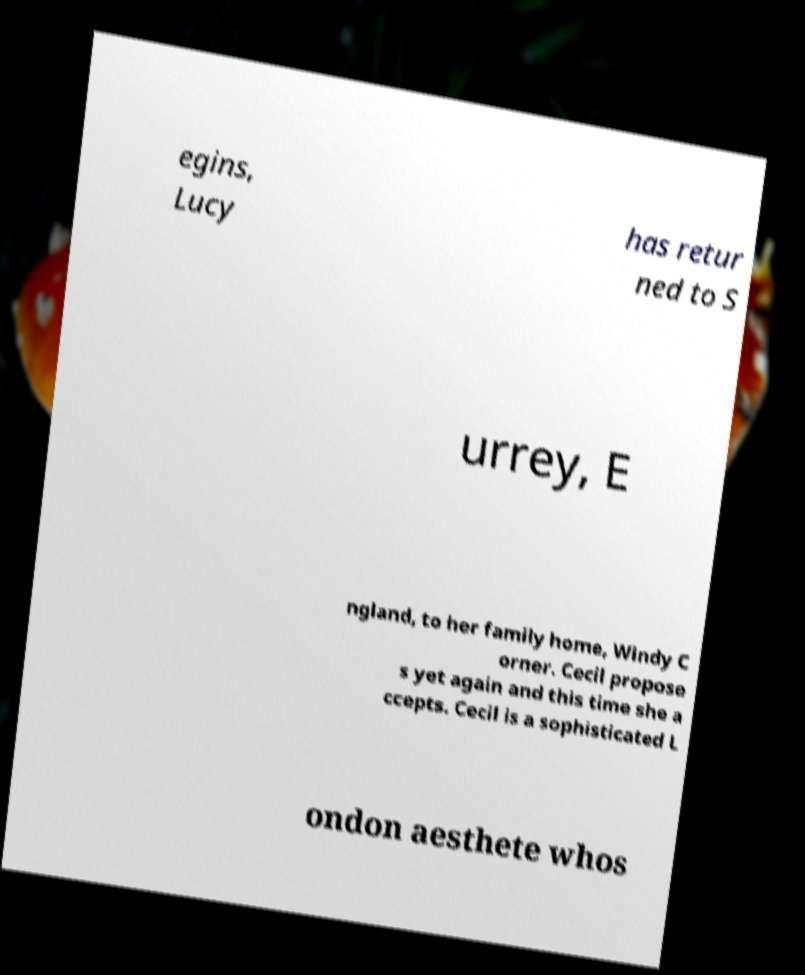I need the written content from this picture converted into text. Can you do that? egins, Lucy has retur ned to S urrey, E ngland, to her family home, Windy C orner. Cecil propose s yet again and this time she a ccepts. Cecil is a sophisticated L ondon aesthete whos 